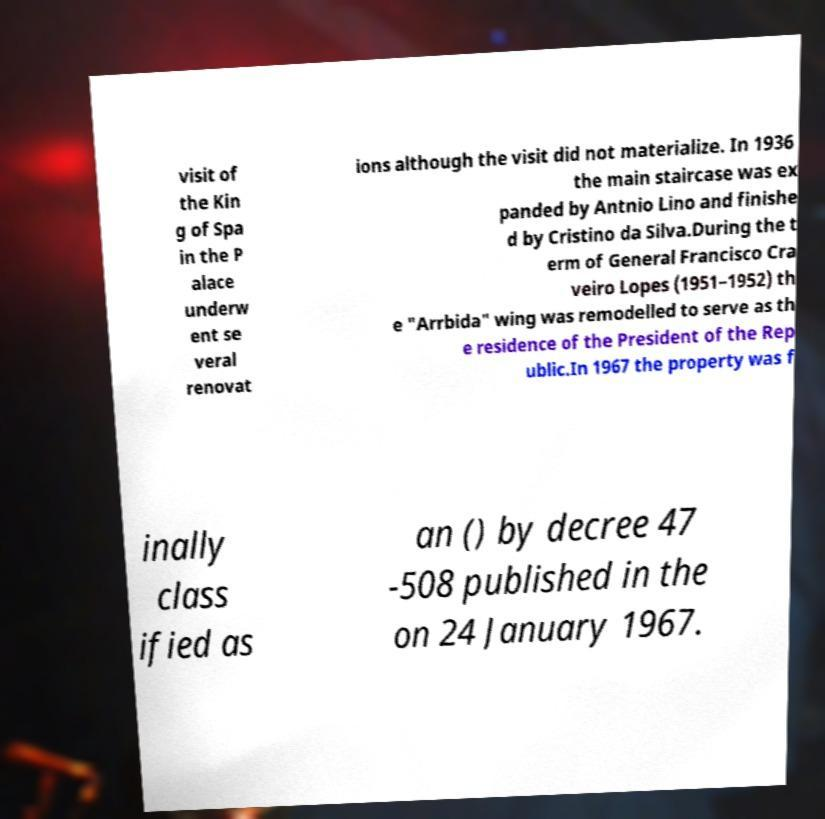Please read and relay the text visible in this image. What does it say? visit of the Kin g of Spa in the P alace underw ent se veral renovat ions although the visit did not materialize. In 1936 the main staircase was ex panded by Antnio Lino and finishe d by Cristino da Silva.During the t erm of General Francisco Cra veiro Lopes (1951–1952) th e "Arrbida" wing was remodelled to serve as th e residence of the President of the Rep ublic.In 1967 the property was f inally class ified as an () by decree 47 -508 published in the on 24 January 1967. 